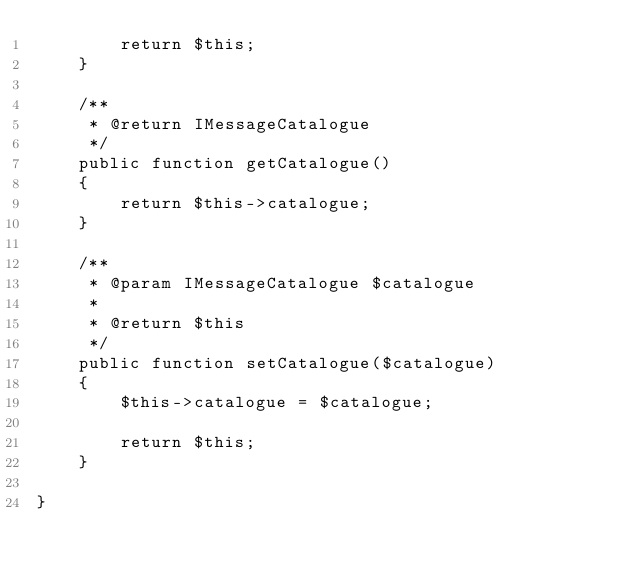Convert code to text. <code><loc_0><loc_0><loc_500><loc_500><_PHP_>        return $this;
    }

    /**
     * @return IMessageCatalogue
     */
    public function getCatalogue()
    {
        return $this->catalogue;
    }

    /**
     * @param IMessageCatalogue $catalogue
     *
     * @return $this
     */
    public function setCatalogue($catalogue)
    {
        $this->catalogue = $catalogue;

        return $this;
    }

}</code> 